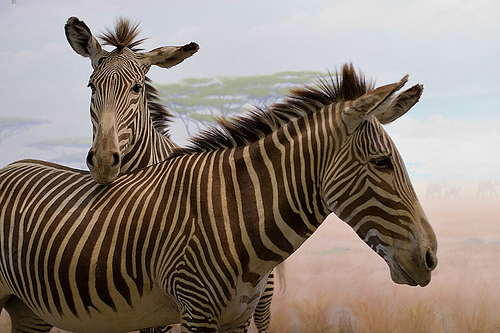Please provide a short description for this region: [0.35, 0.31, 0.79, 0.38]. The highlighted region shows the unique hairs of the zebra which are part of its mane, standing erect and marked with alternating black and white bands. 